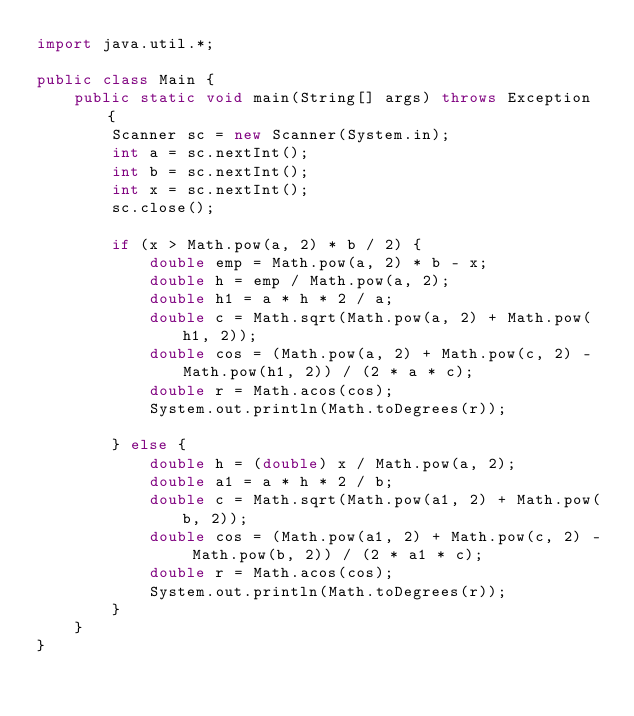<code> <loc_0><loc_0><loc_500><loc_500><_Java_>import java.util.*;

public class Main {
    public static void main(String[] args) throws Exception {
        Scanner sc = new Scanner(System.in);
        int a = sc.nextInt();
        int b = sc.nextInt();
        int x = sc.nextInt();
        sc.close();

        if (x > Math.pow(a, 2) * b / 2) {
            double emp = Math.pow(a, 2) * b - x;
            double h = emp / Math.pow(a, 2);
            double h1 = a * h * 2 / a;
            double c = Math.sqrt(Math.pow(a, 2) + Math.pow(h1, 2));
            double cos = (Math.pow(a, 2) + Math.pow(c, 2) - Math.pow(h1, 2)) / (2 * a * c);
            double r = Math.acos(cos);
            System.out.println(Math.toDegrees(r));

        } else {
            double h = (double) x / Math.pow(a, 2);
            double a1 = a * h * 2 / b;
            double c = Math.sqrt(Math.pow(a1, 2) + Math.pow(b, 2));
            double cos = (Math.pow(a1, 2) + Math.pow(c, 2) - Math.pow(b, 2)) / (2 * a1 * c);
            double r = Math.acos(cos);
            System.out.println(Math.toDegrees(r));
        }
    }
}
</code> 